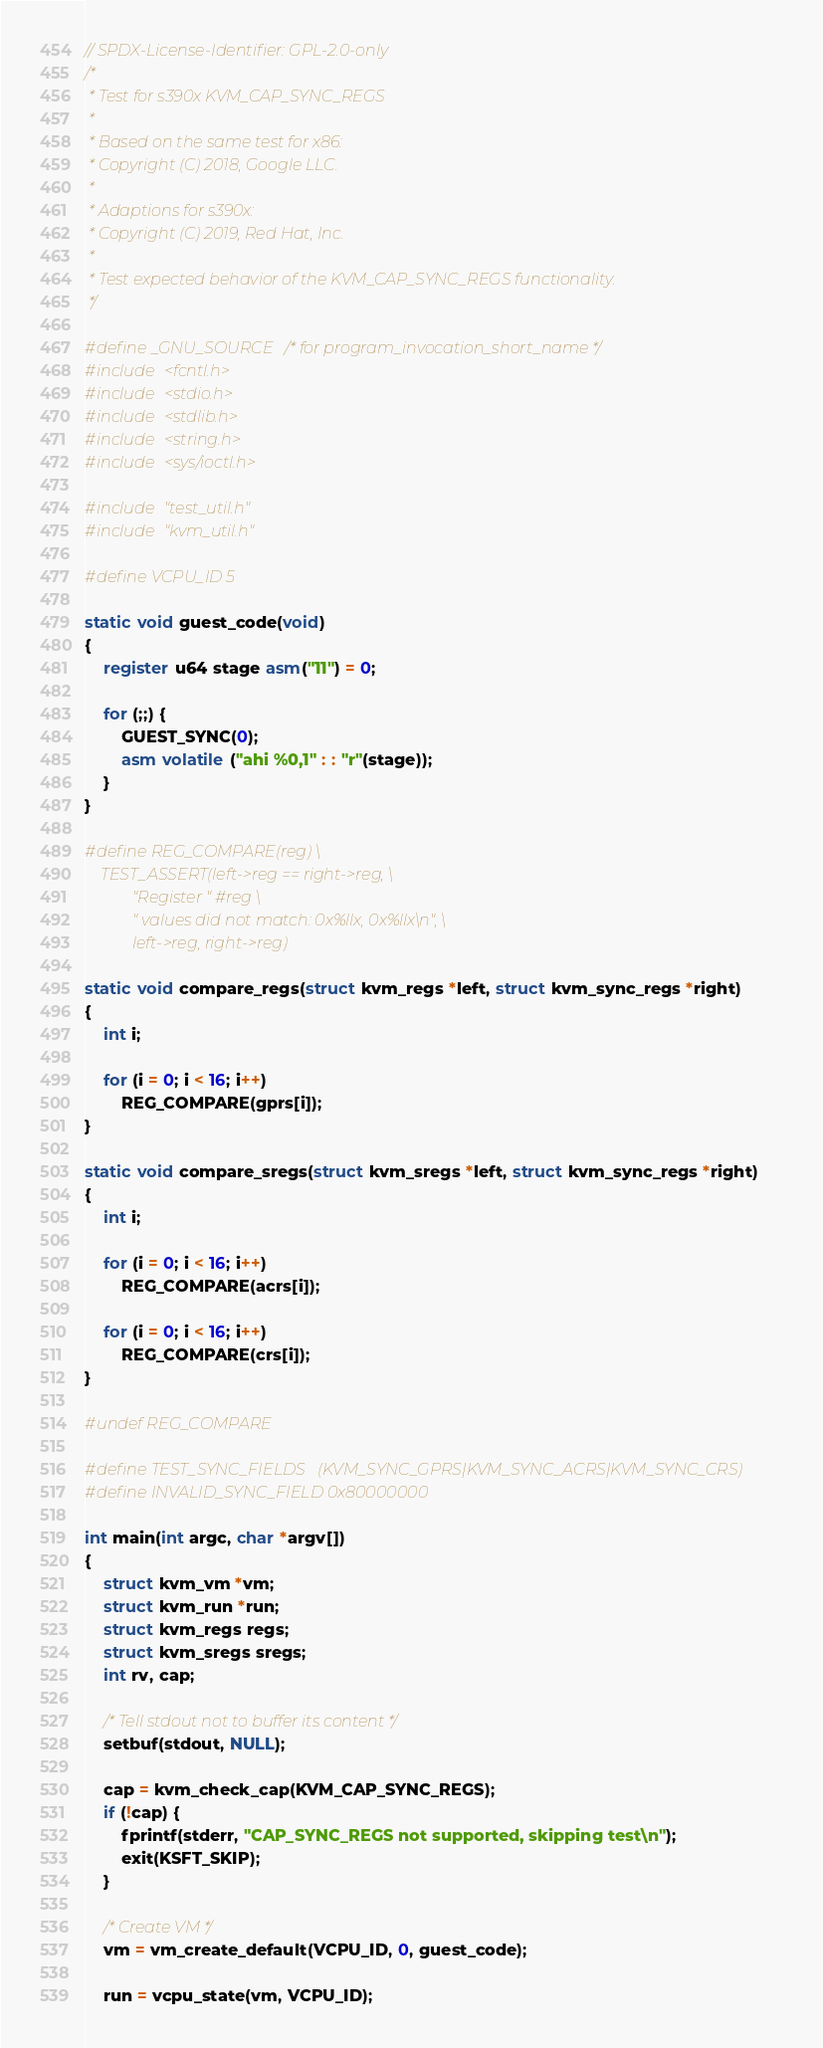<code> <loc_0><loc_0><loc_500><loc_500><_C_>// SPDX-License-Identifier: GPL-2.0-only
/*
 * Test for s390x KVM_CAP_SYNC_REGS
 *
 * Based on the same test for x86:
 * Copyright (C) 2018, Google LLC.
 *
 * Adaptions for s390x:
 * Copyright (C) 2019, Red Hat, Inc.
 *
 * Test expected behavior of the KVM_CAP_SYNC_REGS functionality.
 */

#define _GNU_SOURCE /* for program_invocation_short_name */
#include <fcntl.h>
#include <stdio.h>
#include <stdlib.h>
#include <string.h>
#include <sys/ioctl.h>

#include "test_util.h"
#include "kvm_util.h"

#define VCPU_ID 5

static void guest_code(void)
{
	register u64 stage asm("11") = 0;

	for (;;) {
		GUEST_SYNC(0);
		asm volatile ("ahi %0,1" : : "r"(stage));
	}
}

#define REG_COMPARE(reg) \
	TEST_ASSERT(left->reg == right->reg, \
		    "Register " #reg \
		    " values did not match: 0x%llx, 0x%llx\n", \
		    left->reg, right->reg)

static void compare_regs(struct kvm_regs *left, struct kvm_sync_regs *right)
{
	int i;

	for (i = 0; i < 16; i++)
		REG_COMPARE(gprs[i]);
}

static void compare_sregs(struct kvm_sregs *left, struct kvm_sync_regs *right)
{
	int i;

	for (i = 0; i < 16; i++)
		REG_COMPARE(acrs[i]);

	for (i = 0; i < 16; i++)
		REG_COMPARE(crs[i]);
}

#undef REG_COMPARE

#define TEST_SYNC_FIELDS   (KVM_SYNC_GPRS|KVM_SYNC_ACRS|KVM_SYNC_CRS)
#define INVALID_SYNC_FIELD 0x80000000

int main(int argc, char *argv[])
{
	struct kvm_vm *vm;
	struct kvm_run *run;
	struct kvm_regs regs;
	struct kvm_sregs sregs;
	int rv, cap;

	/* Tell stdout not to buffer its content */
	setbuf(stdout, NULL);

	cap = kvm_check_cap(KVM_CAP_SYNC_REGS);
	if (!cap) {
		fprintf(stderr, "CAP_SYNC_REGS not supported, skipping test\n");
		exit(KSFT_SKIP);
	}

	/* Create VM */
	vm = vm_create_default(VCPU_ID, 0, guest_code);

	run = vcpu_state(vm, VCPU_ID);
</code> 